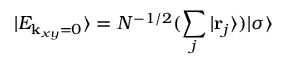Convert formula to latex. <formula><loc_0><loc_0><loc_500><loc_500>| E _ { { k } _ { x y } = 0 } \rangle = N ^ { - 1 / 2 } ( \sum _ { j } | { r } _ { j } \rangle ) | \sigma \rangle</formula> 